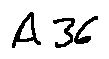Convert formula to latex. <formula><loc_0><loc_0><loc_500><loc_500>A 3 6</formula> 